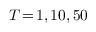<formula> <loc_0><loc_0><loc_500><loc_500>T \, = \, 1 , 1 0 , 5 0</formula> 